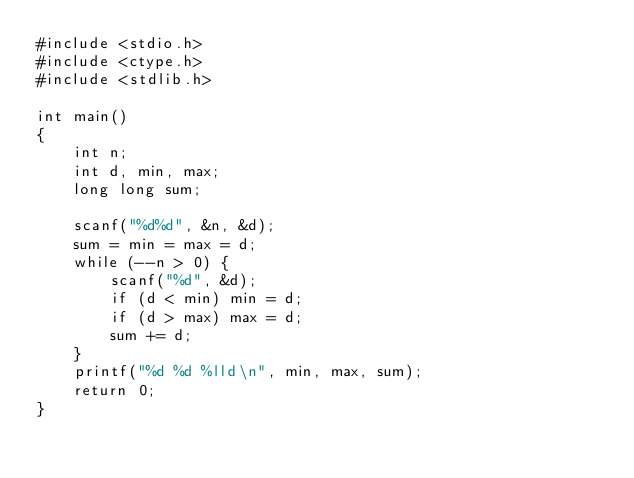Convert code to text. <code><loc_0><loc_0><loc_500><loc_500><_C_>#include <stdio.h>
#include <ctype.h>
#include <stdlib.h>
 
int main()
{
    int n;
    int d, min, max;
    long long sum;
 
    scanf("%d%d", &n, &d);
    sum = min = max = d;
    while (--n > 0) {
        scanf("%d", &d);
        if (d < min) min = d;
        if (d > max) max = d;
        sum += d;
    }
    printf("%d %d %lld\n", min, max, sum);
    return 0;
}
</code> 